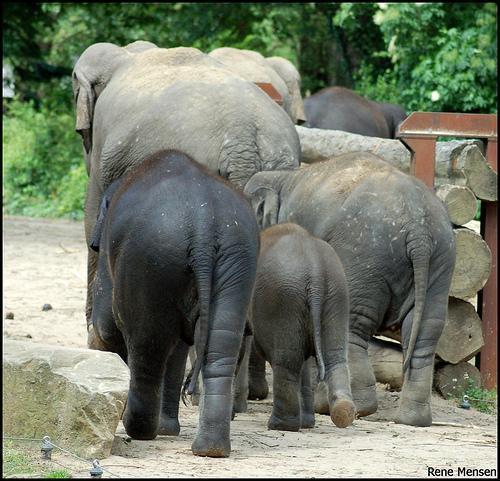How many elephants are there?
Give a very brief answer. 6. 